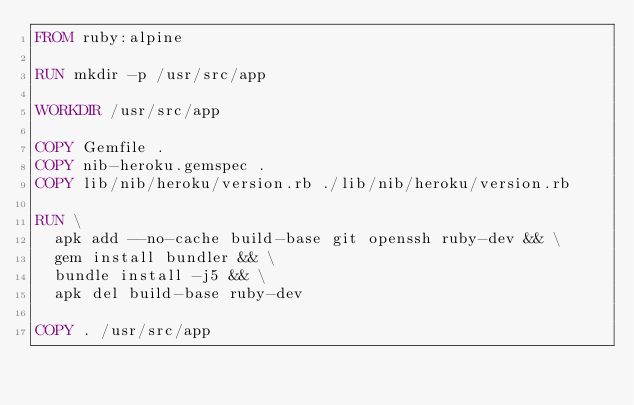<code> <loc_0><loc_0><loc_500><loc_500><_Dockerfile_>FROM ruby:alpine

RUN mkdir -p /usr/src/app

WORKDIR /usr/src/app

COPY Gemfile .
COPY nib-heroku.gemspec .
COPY lib/nib/heroku/version.rb ./lib/nib/heroku/version.rb

RUN \
  apk add --no-cache build-base git openssh ruby-dev && \
  gem install bundler && \
  bundle install -j5 && \
  apk del build-base ruby-dev

COPY . /usr/src/app
</code> 